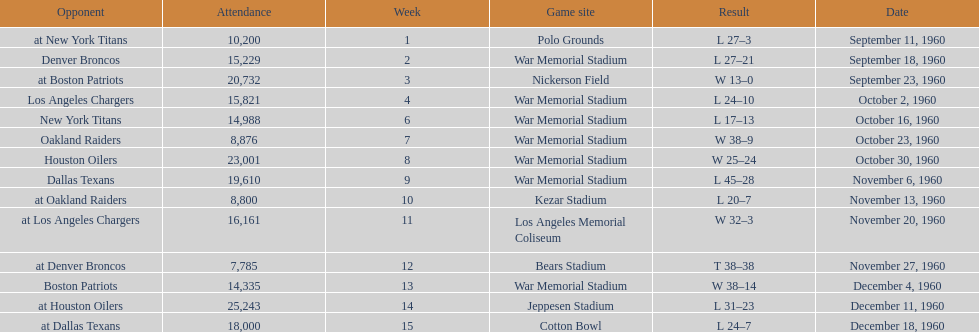What was the largest difference of points in a single game? 29. 